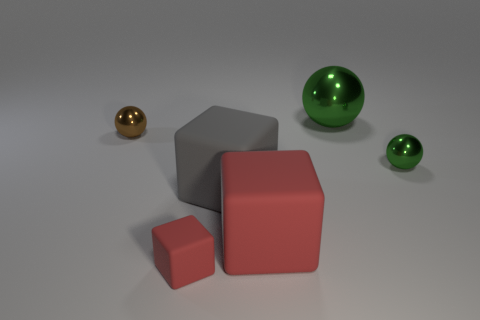Subtract all red matte blocks. How many blocks are left? 1 Add 1 rubber cylinders. How many objects exist? 7 Subtract all red blocks. How many blocks are left? 1 Subtract 2 cubes. How many cubes are left? 1 Subtract all blue blocks. Subtract all red cylinders. How many blocks are left? 3 Subtract all blue balls. How many purple blocks are left? 0 Subtract all small rubber cubes. Subtract all brown metal objects. How many objects are left? 4 Add 4 large green shiny objects. How many large green shiny objects are left? 5 Add 5 gray blocks. How many gray blocks exist? 6 Subtract 0 yellow balls. How many objects are left? 6 